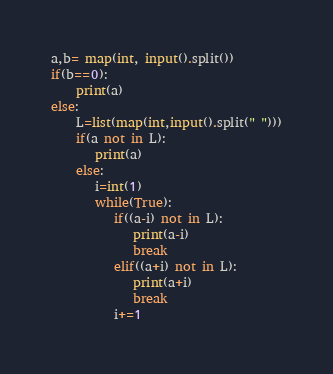<code> <loc_0><loc_0><loc_500><loc_500><_Python_>a,b= map(int, input().split())
if(b==0):
    print(a)
else:
    L=list(map(int,input().split(" ")))
    if(a not in L):
       print(a)
    else:
       i=int(1)
       while(True):
          if((a-i) not in L):
             print(a-i)
             break
          elif((a+i) not in L):
             print(a+i)
             break
          i+=1

</code> 